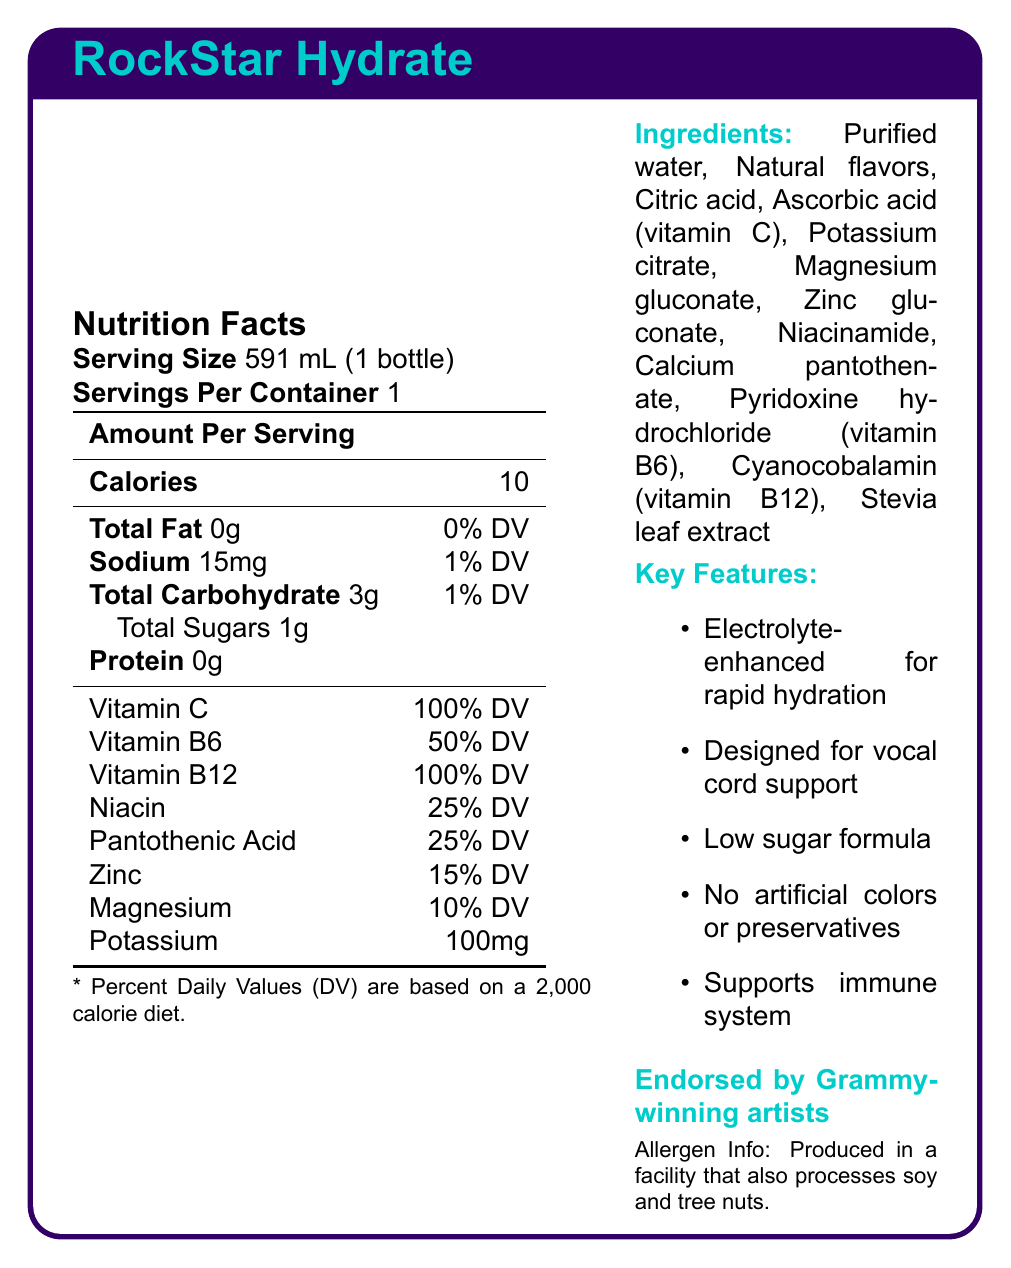what is the serving size for RockStar Hydrate? The serving size is plainly listed as "591 mL (1 bottle)" under the Nutrition Facts section.
Answer: 591 mL (1 bottle) how many calories are there per serving? The document specifies "Calories: 10" directly under the Amount Per Serving heading in the Nutrition Facts section.
Answer: 10 calories what percentage of the Daily Value (% DV) of vitamin C does one serving provide? The % DV for vitamin C is listed as 100% in the table under the Nutrition Facts section.
Answer: 100% DV how much sodium is in each serving? Sodium content is listed as "15mg" in the Nutrition Facts section.
Answer: 15mg what is the first ingredient listed? In the Ingredients section, the first item listed is "Purified water."
Answer: Purified water which vitamins are provided at 100% Daily Value per serving? A. Vitamin C and Vitamin B6 B. Vitamin C and Vitamin B12 C. Niacin and Pantothenic Acid D. Zinc and Magnesium The Nutrition Facts section indicates both Vitamin C and Vitamin B12 are at 100% DV per serving.
Answer: B which of the following best describes the target audience for RockStar Hydrate? A. Professional athletes B. Business executives C. Touring musicians D. College students The additional info and marketing claims sections emphasize that the product is designed for musicians, particularly for vocal cord support and maintaining stamina during long studio sessions.
Answer: C is RockStar Hydrate suitable for someone avoiding artificial preservatives? The additional information section clearly states that the product contains "No artificial colors or preservatives."
Answer: Yes list two features of RockStar Hydrate that contribute to rapid hydration. These features are listed in the Key Features section.
Answer: Electrolyte-enhanced for rapid hydration, designed for vocal cord support name three vitamins or minerals included in RockStar Hydrate and their respective % DV. These values are listed in the table under the Nutrition Facts section.
Answer: Vitamin C 100% DV, Vitamin B6 50% DV, Zinc 15% DV are there any allergens in RockStar Hydrate? The allergen information at the bottom of the document states it is produced in a facility that processes soy and tree nuts, though it doesn't confirm their presence in the product itself.
Answer: Produced in a facility that also processes soy and tree nuts. can you mention any marketing claims associated with RockStar Hydrate? These are listed as marketing claims in the document.
Answer: Formulated by music industry nutritionists, endorsed by Grammy-winning artists, perfect for pre-show hydration and post-performance recovery, helps maintain stamina for long studio sessions. describe the main idea of this document. The summary covers the product name, the target audience, nutritional information, ingredients, features, and marketing emphasis.
Answer: The document provides a detailed overview of RockStar Hydrate, a vitamin-enriched, low-calorie water designed for touring musicians. It highlights its nutritional content, ingredients, key features, and suitability for vocal cord support and rapid hydration. what is the country of origin for RockStar Hydrate? The document does not provide information on where the product is manufactured.
Answer: Cannot be determined 